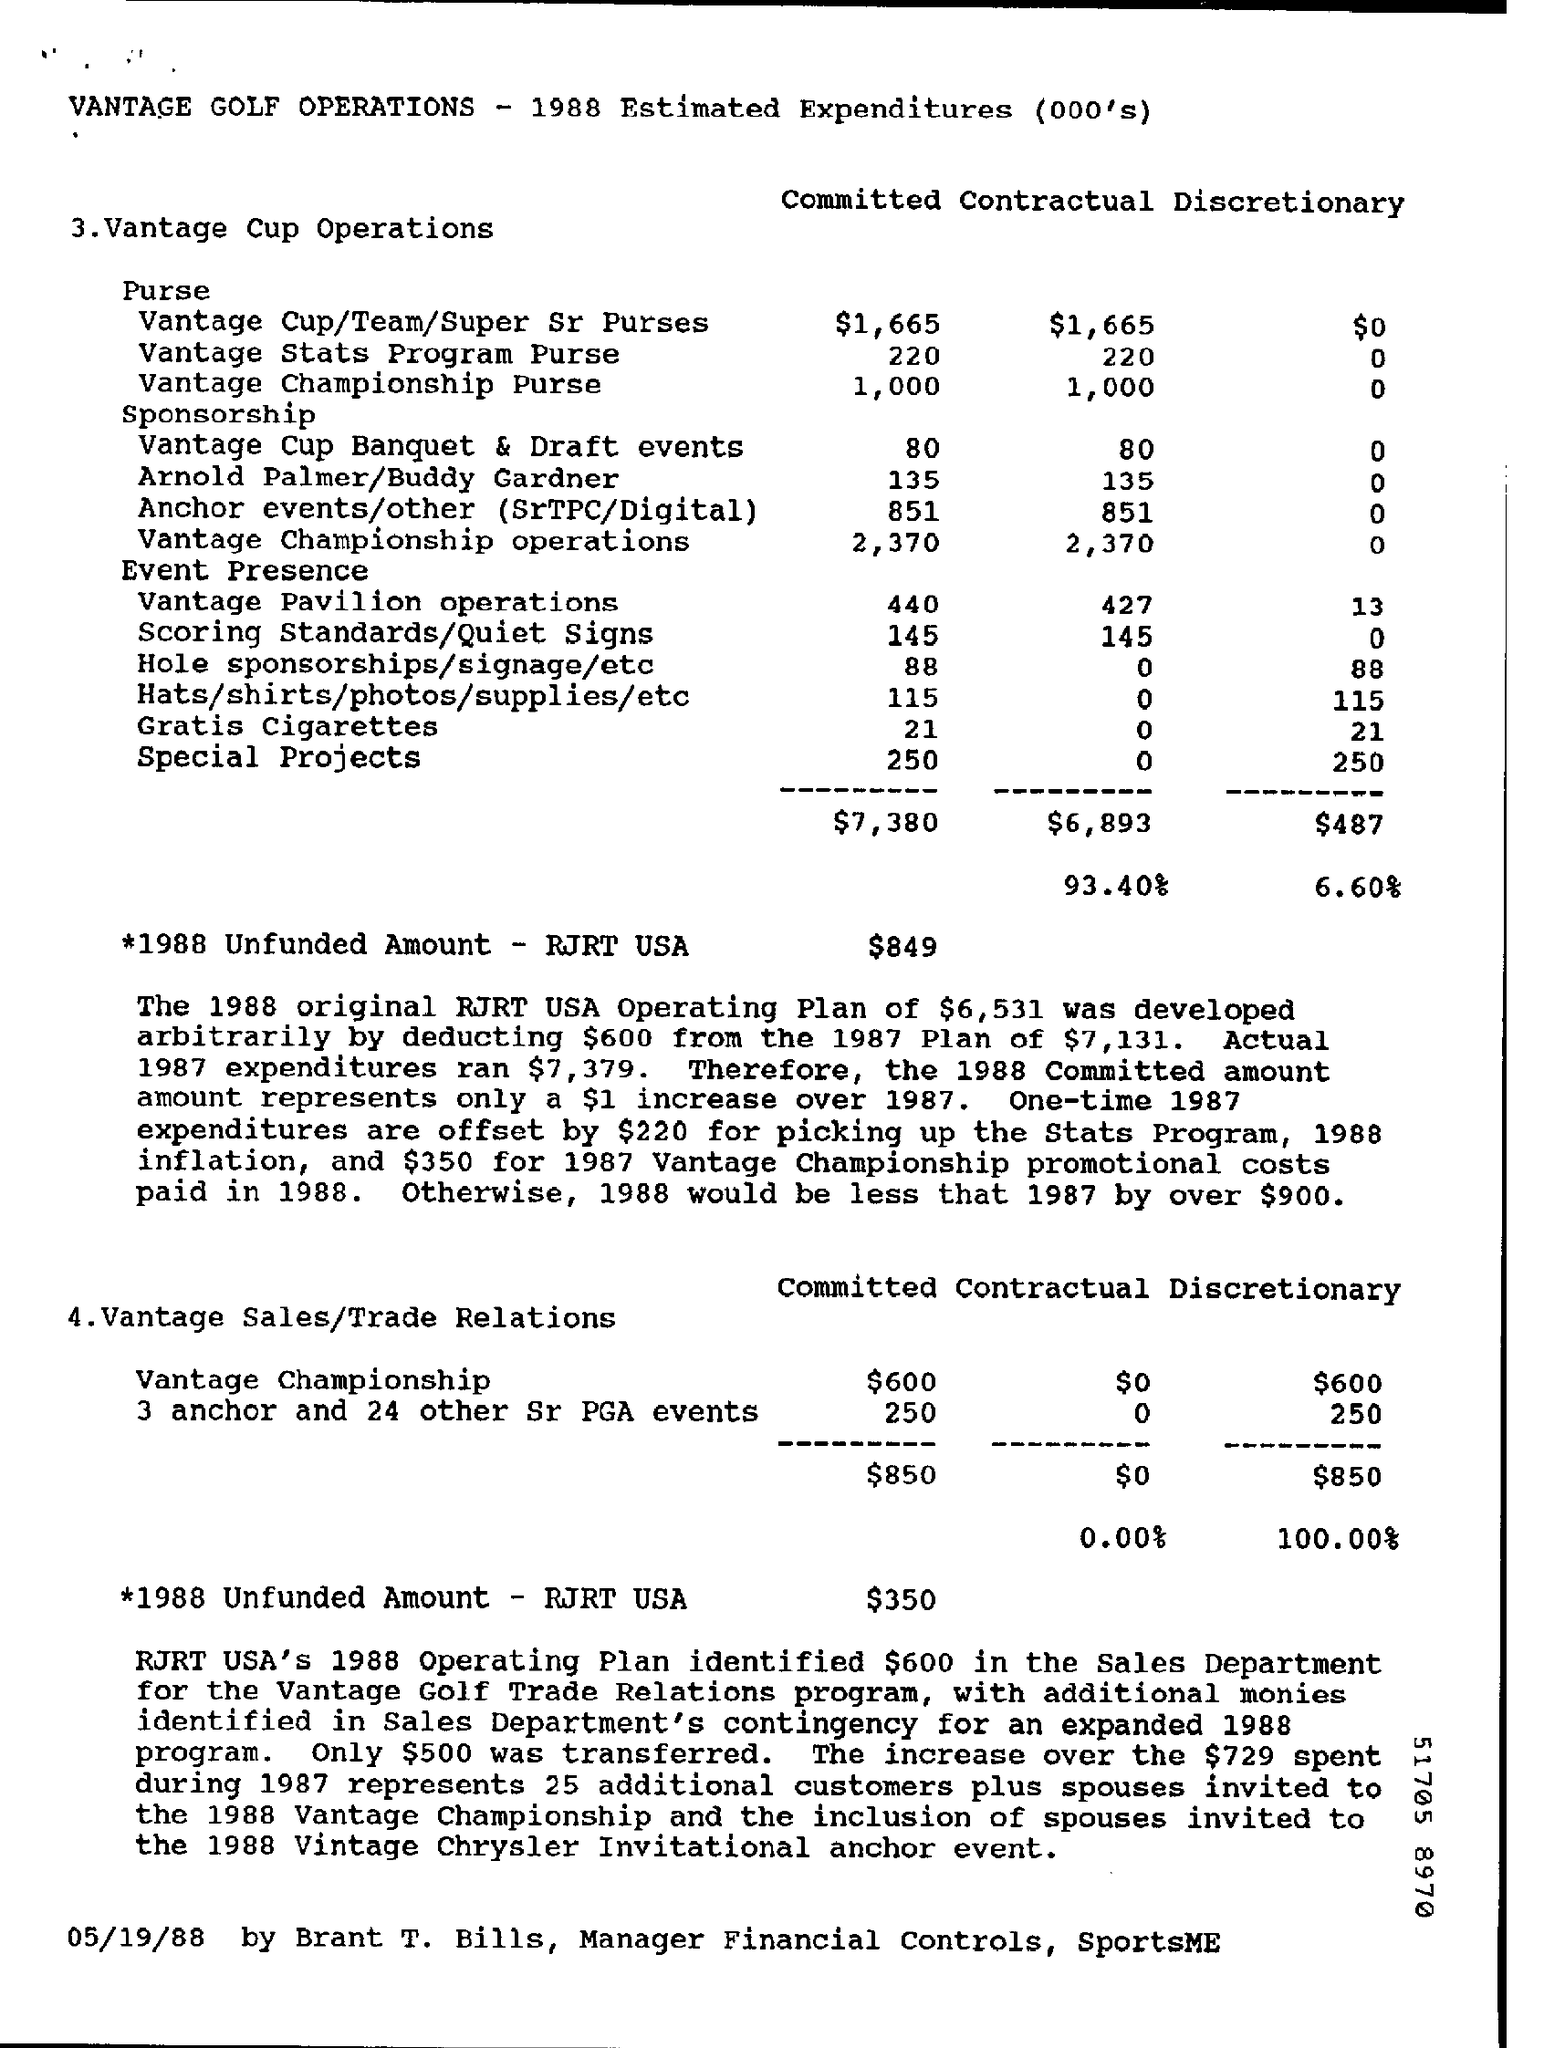How much is the Committed Vantage Championship Purse cost ?
Offer a terse response. 1,000. How much is the 1988 Unfunded Amount - RJRT USA for Vantage cup Operations?
Give a very brief answer. $849. How much was the actual 1987 expenditures?
Offer a terse response. $7,379. How much is the committed cost of vantage Sales/Trade relations for vantage championship ?
Provide a short and direct response. $600. Who is the Manager Financial Controls of SportsME ?
Ensure brevity in your answer.  Brant T. Bills. 